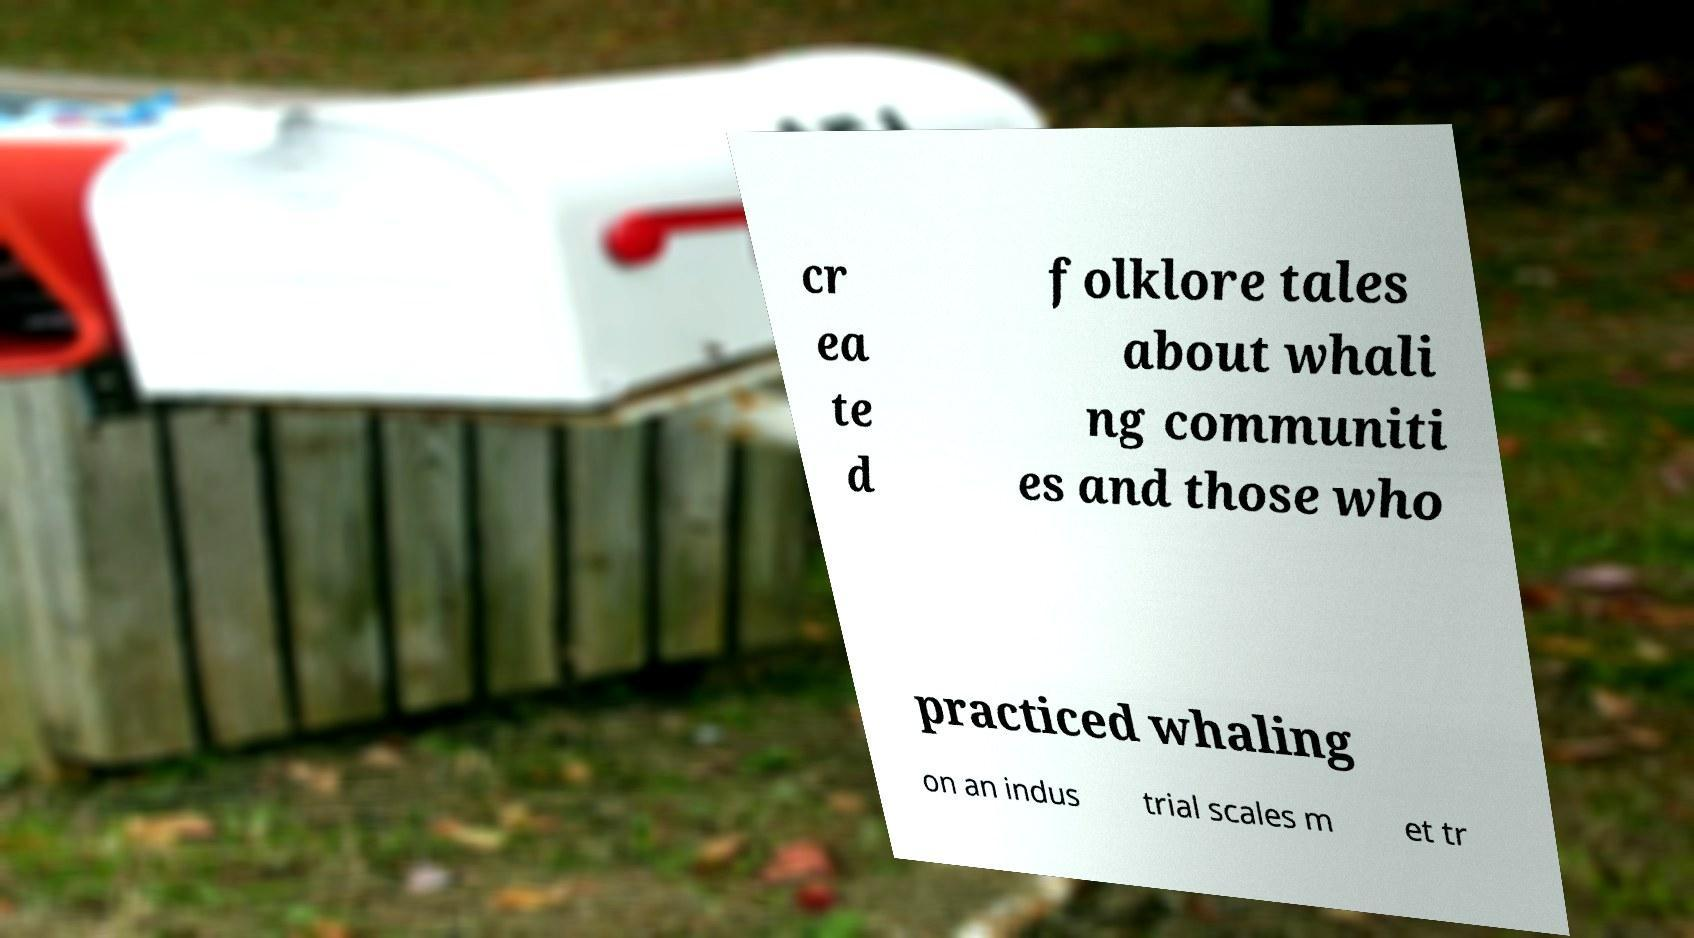For documentation purposes, I need the text within this image transcribed. Could you provide that? cr ea te d folklore tales about whali ng communiti es and those who practiced whaling on an indus trial scales m et tr 